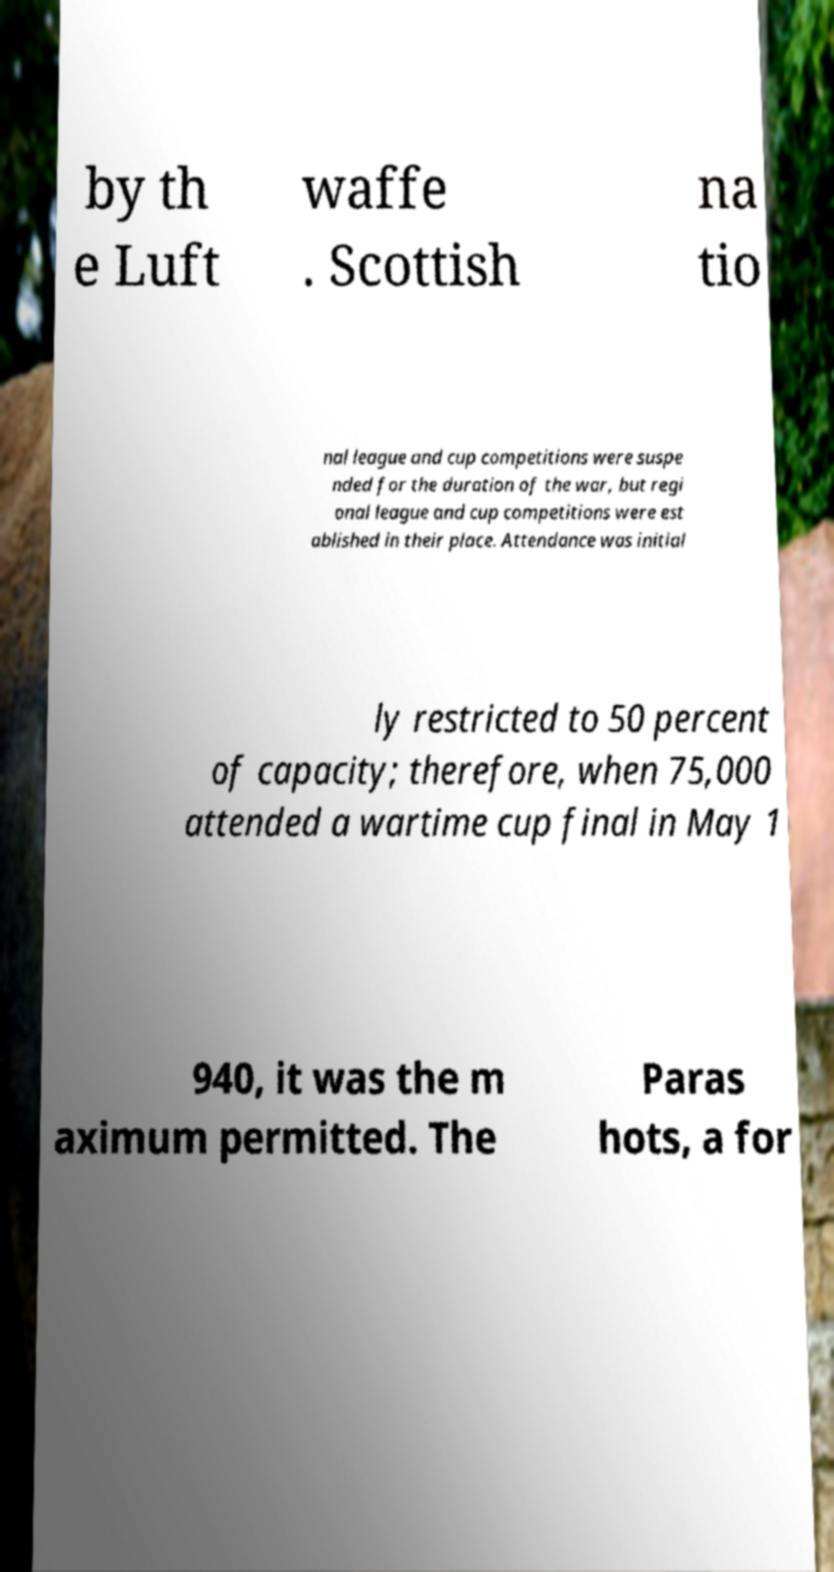Could you extract and type out the text from this image? by th e Luft waffe . Scottish na tio nal league and cup competitions were suspe nded for the duration of the war, but regi onal league and cup competitions were est ablished in their place. Attendance was initial ly restricted to 50 percent of capacity; therefore, when 75,000 attended a wartime cup final in May 1 940, it was the m aximum permitted. The Paras hots, a for 